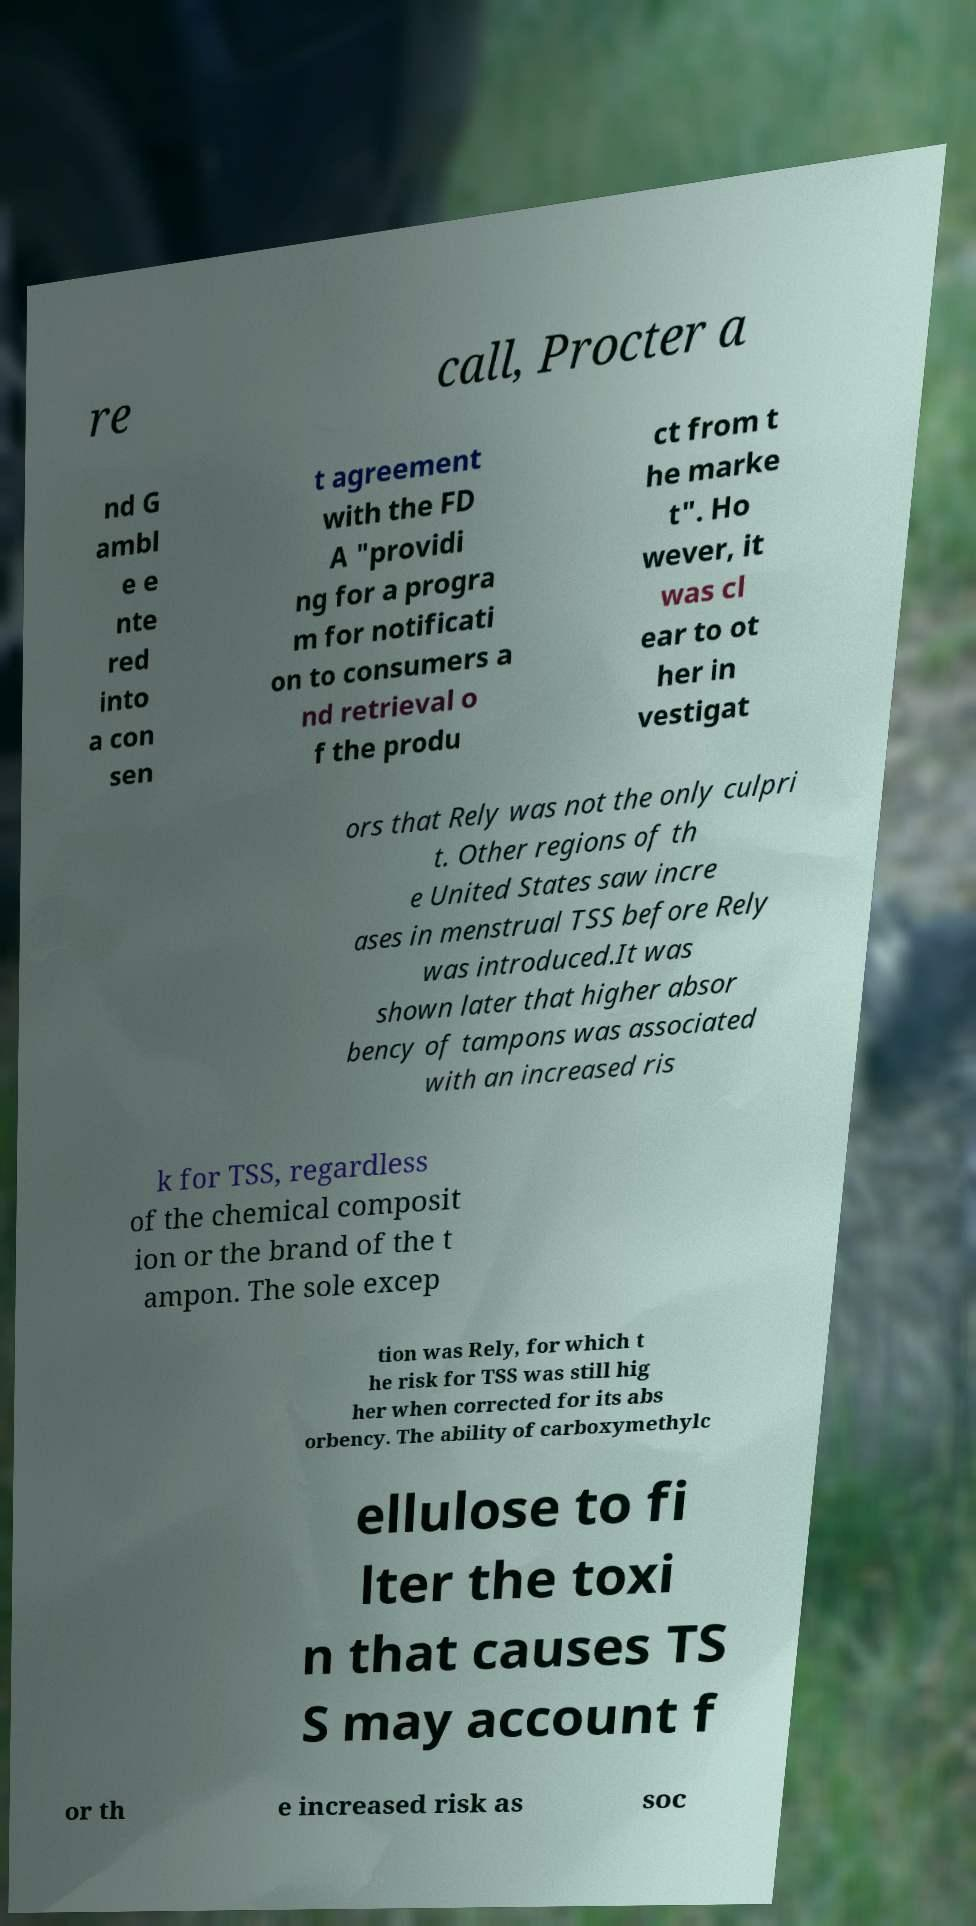Can you read and provide the text displayed in the image?This photo seems to have some interesting text. Can you extract and type it out for me? re call, Procter a nd G ambl e e nte red into a con sen t agreement with the FD A "providi ng for a progra m for notificati on to consumers a nd retrieval o f the produ ct from t he marke t". Ho wever, it was cl ear to ot her in vestigat ors that Rely was not the only culpri t. Other regions of th e United States saw incre ases in menstrual TSS before Rely was introduced.It was shown later that higher absor bency of tampons was associated with an increased ris k for TSS, regardless of the chemical composit ion or the brand of the t ampon. The sole excep tion was Rely, for which t he risk for TSS was still hig her when corrected for its abs orbency. The ability of carboxymethylc ellulose to fi lter the toxi n that causes TS S may account f or th e increased risk as soc 